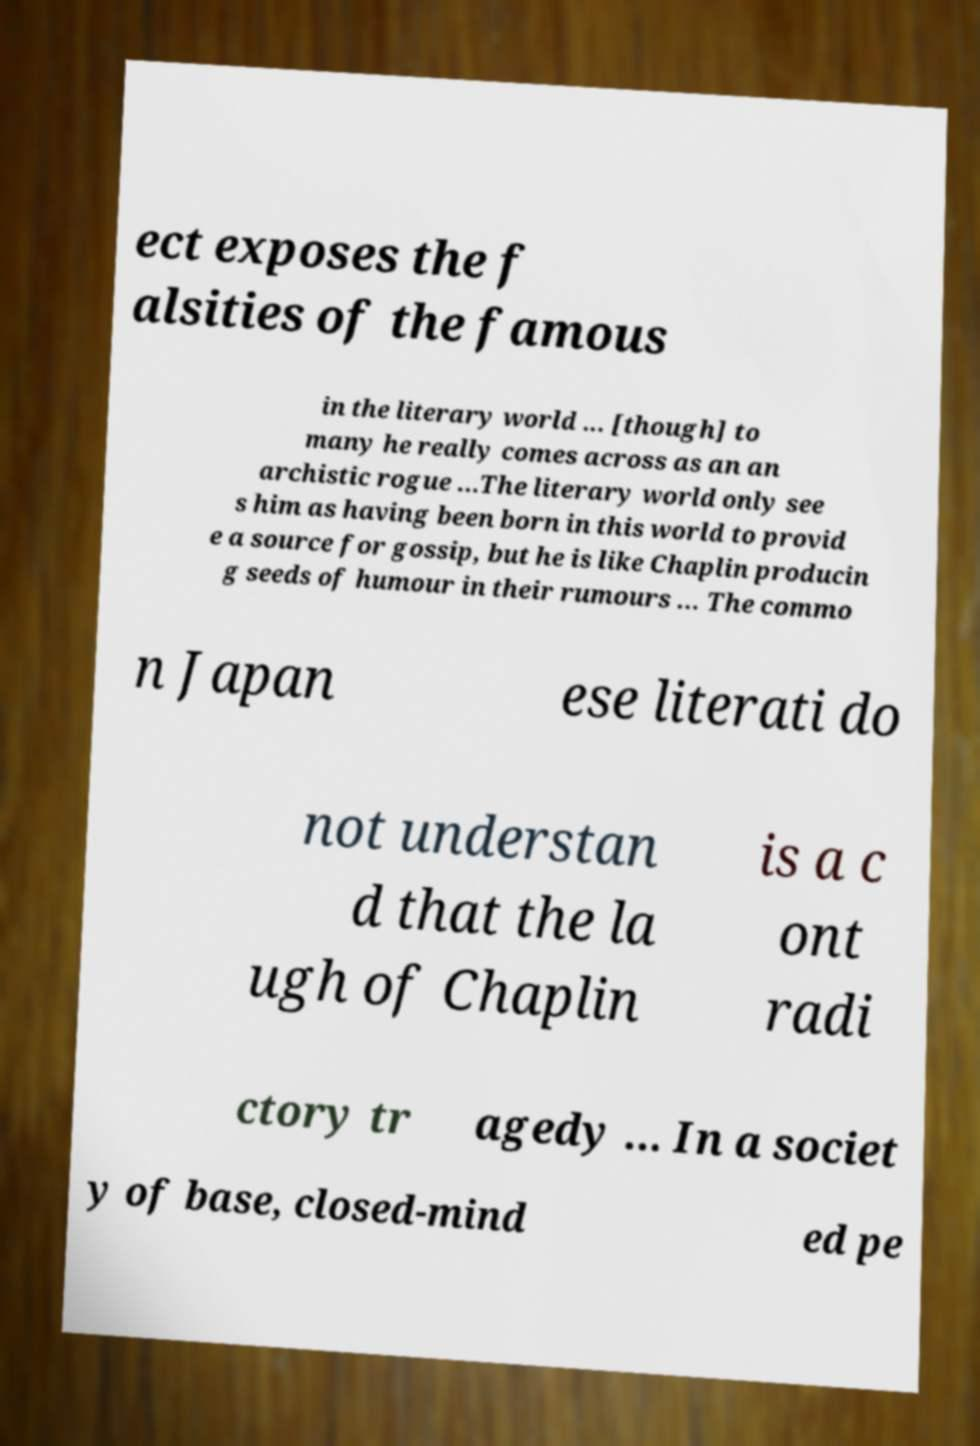Can you read and provide the text displayed in the image?This photo seems to have some interesting text. Can you extract and type it out for me? ect exposes the f alsities of the famous in the literary world ... [though] to many he really comes across as an an archistic rogue ...The literary world only see s him as having been born in this world to provid e a source for gossip, but he is like Chaplin producin g seeds of humour in their rumours ... The commo n Japan ese literati do not understan d that the la ugh of Chaplin is a c ont radi ctory tr agedy ... In a societ y of base, closed-mind ed pe 